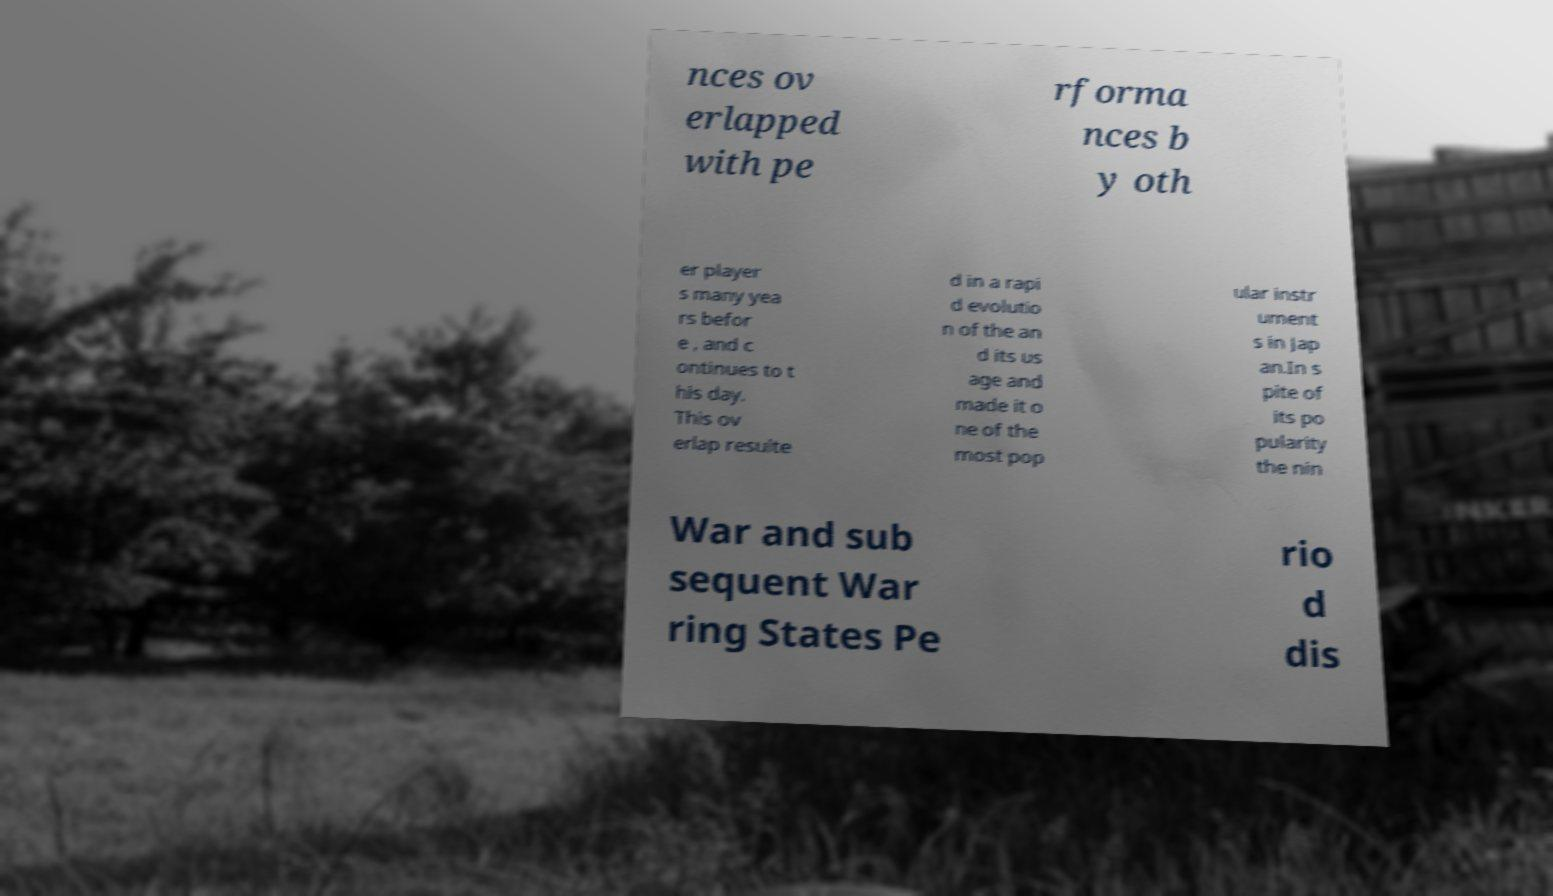Could you extract and type out the text from this image? nces ov erlapped with pe rforma nces b y oth er player s many yea rs befor e , and c ontinues to t his day. This ov erlap resulte d in a rapi d evolutio n of the an d its us age and made it o ne of the most pop ular instr ument s in Jap an.In s pite of its po pularity the nin War and sub sequent War ring States Pe rio d dis 